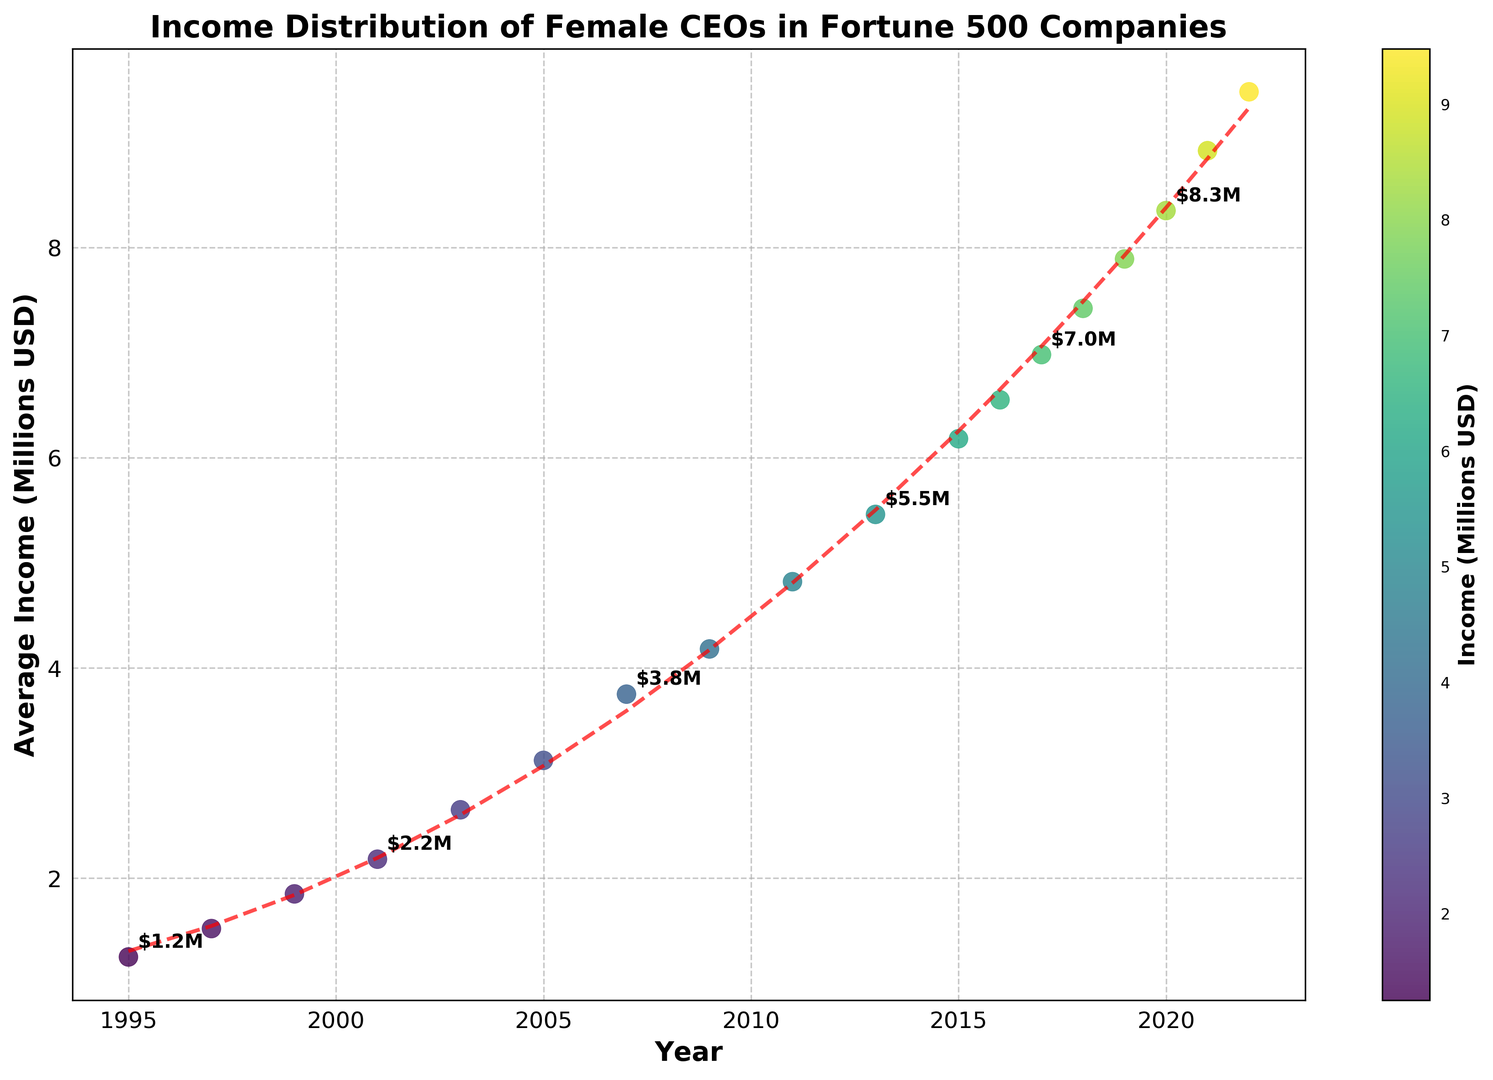What is the trend of the average income of female CEOs in Fortune 500 companies from 1995 to 2022? The scatter plot shows a clear upward trend in the average income of female CEOs from 1995 to 2022, as indicated by the rising data points and the red dashed polynomial trend line.
Answer: Upward trend Which year shows the most significant increase in average income compared to the previous year? By observing the scatter plot, we notice the largest jump between two consecutive points from 2011 to 2013. The income increases from about 4.82 million USD in 2011 to 5.46 million USD in 2013.
Answer: 2013 During which years was the average income of female CEOs annotated with values above $6 million? The annotations above $6 million can be observed in the years 2015, 2016, 2017, 2018, 2019, 2020, 2021, and 2022, indicated by the labeled points above the 6 million line.
Answer: 2015-2022 What’s the difference in average income between 1995 and 2022? Looking at the figure, the average income in 1995 was approximately 1.25 million USD, and in 2022 it was approximately 9.48 million USD. The difference is 9.48 - 1.25 = 8.23 million USD.
Answer: 8.23 million USD How does the width of the colorbar relate to the overall incomes shown on the scatter plot? The colorbar on the right shows a gradual color scale from lower to higher incomes, corresponding to the colors of the scatter plot points. Incomes increase as the color changes from blue to yellow.
Answer: Colors represent income levels Which point has the darkest shade in the scatter plot, and what does it indicate about the income? The darkest shade point is around 1995, as indicated by the darkest blue color on the scatter plot and colorbar, which shows the lowest income value of approximately 1.25 million USD.
Answer: 1995 (1.25 million USD) What is the approximate range of average incomes represented in the scatter plot? By examining the y-axis, the smallest value appears to be around 1.25 million USD in 1995, while the largest value is around 9.48 million USD in 2022. So the range is 9.48 - 1.25 = 8.23 million USD.
Answer: 1.25 million - 9.48 million USD How does the trendline help in understanding the overall pattern of income growth? The red dashed polynomial trendline fits the scatter points and emphasizes the overall growth pattern despite yearly fluctuations, confirming a consistent upward trajectory in average incomes over time.
Answer: Indicates upward trajectory 